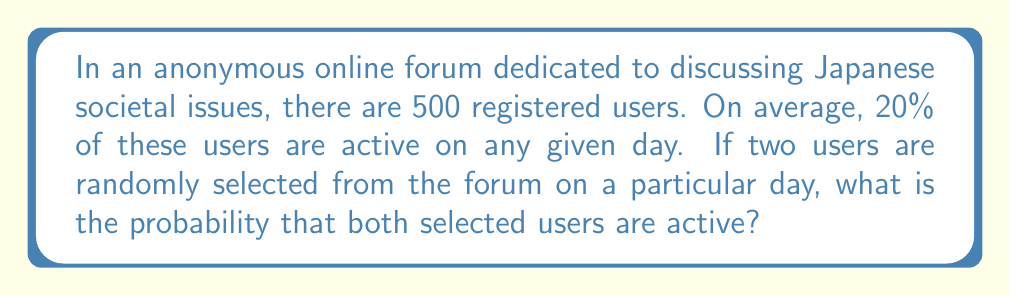Help me with this question. Let's approach this step-by-step:

1) First, we need to determine the number of active users on any given day:
   $500 \times 20\% = 500 \times 0.20 = 100$ active users

2) Now, we can use the probability formula for selecting two active users without replacement:

   $P(\text{both active}) = \frac{\text{favorable outcomes}}{\text{total outcomes}} = \frac{{}^{100}C_2}{{}^{500}C_2}$

3) Let's calculate the numerator (favorable outcomes):
   ${}^{100}C_2 = \frac{100!}{2!(100-2)!} = \frac{100 \times 99}{2} = 4950$

4) Now, let's calculate the denominator (total outcomes):
   ${}^{500}C_2 = \frac{500!}{2!(500-2)!} = \frac{500 \times 499}{2} = 124750$

5) Therefore, the probability is:
   $P(\text{both active}) = \frac{4950}{124750} = \frac{99}{2495} \approx 0.0396$

This can be converted to a percentage: $0.0396 \times 100\% = 3.96\%$
Answer: $3.96\%$ 